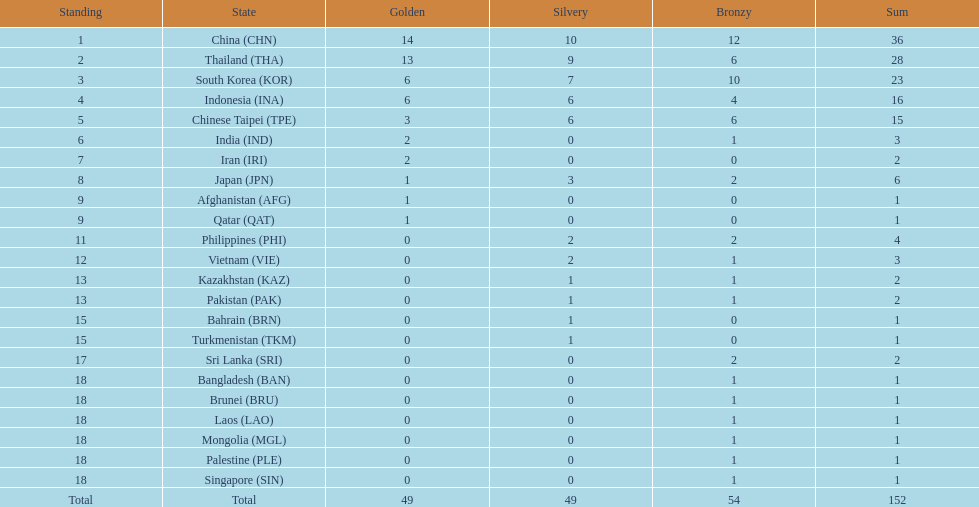How many nations won no silver medals at all? 11. 